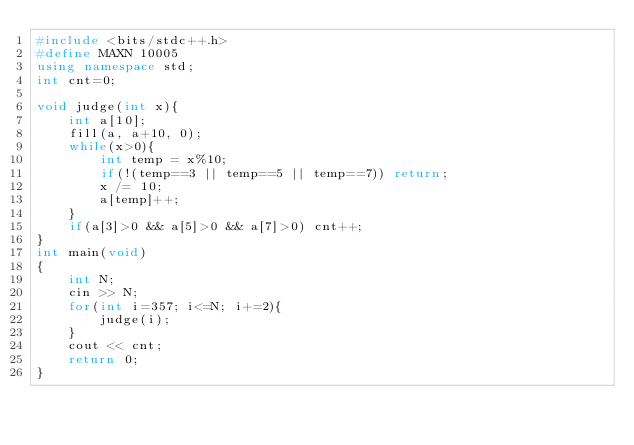Convert code to text. <code><loc_0><loc_0><loc_500><loc_500><_C++_>#include <bits/stdc++.h>
#define MAXN 10005
using namespace std;
int cnt=0;

void judge(int x){
    int a[10];
    fill(a, a+10, 0);
    while(x>0){
        int temp = x%10;
        if(!(temp==3 || temp==5 || temp==7)) return;
        x /= 10;
        a[temp]++;
    }
    if(a[3]>0 && a[5]>0 && a[7]>0) cnt++;
}
int main(void)
{
    int N;
    cin >> N;
    for(int i=357; i<=N; i+=2){
        judge(i);
    }
    cout << cnt;
    return 0;
}
</code> 